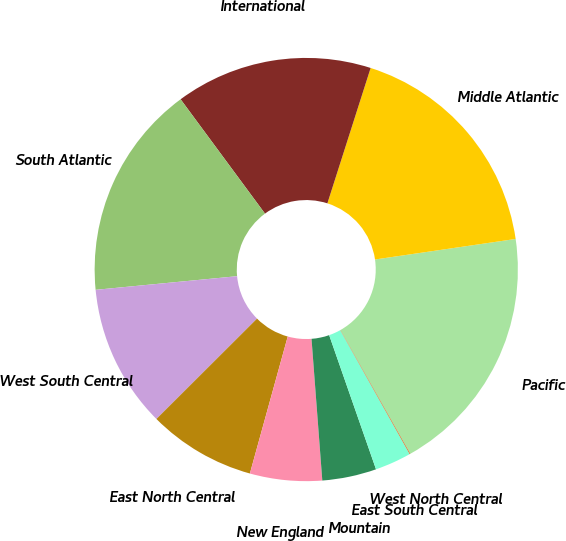Convert chart to OTSL. <chart><loc_0><loc_0><loc_500><loc_500><pie_chart><fcel>Pacific<fcel>Middle Atlantic<fcel>International<fcel>South Atlantic<fcel>West South Central<fcel>East North Central<fcel>New England<fcel>Mountain<fcel>East South Central<fcel>West North Central<nl><fcel>19.13%<fcel>17.77%<fcel>15.04%<fcel>16.41%<fcel>10.95%<fcel>8.23%<fcel>5.5%<fcel>4.14%<fcel>2.78%<fcel>0.05%<nl></chart> 